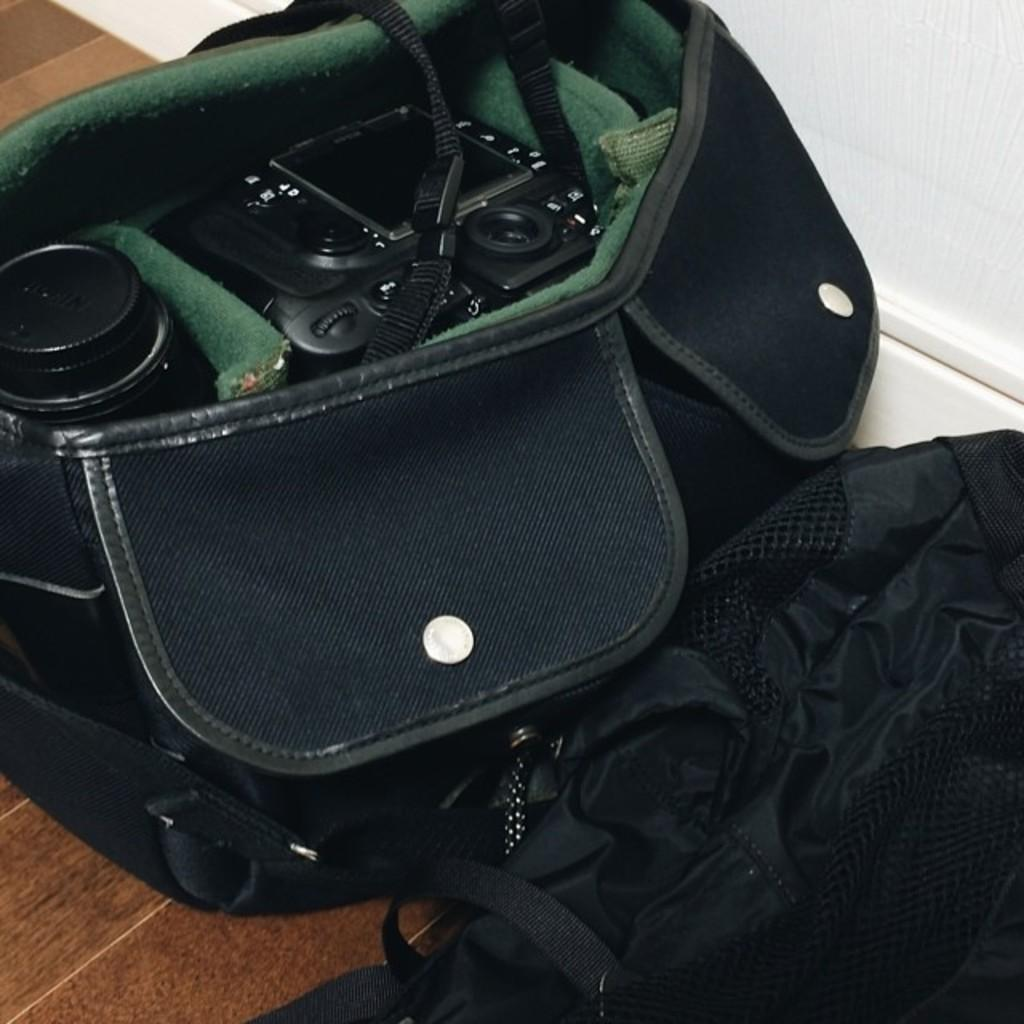What color are the bags on the floor in the image? The bags on the floor are black-colored. What is located near or inside the bags? A camera and a lens are present in or near the bags. What type of locket can be seen hanging from the camera in the image? There is no locket present in the image; only the bags, camera, and lens are visible. What does the clam smell like in the image? There is no clam present in the image, so it cannot be determined what it might smell like. 